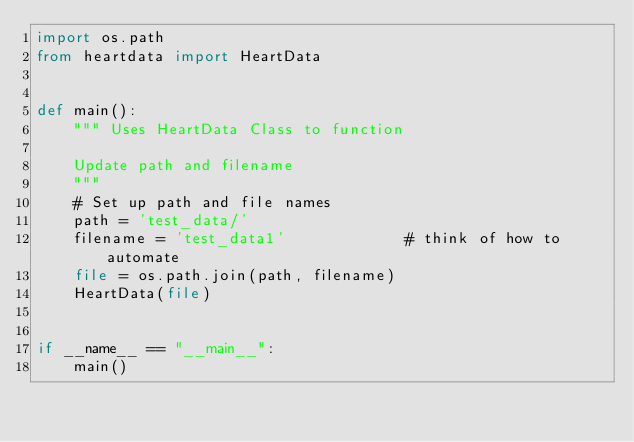Convert code to text. <code><loc_0><loc_0><loc_500><loc_500><_Python_>import os.path
from heartdata import HeartData


def main():
    """ Uses HeartData Class to function

    Update path and filename
    """
    # Set up path and file names
    path = 'test_data/'
    filename = 'test_data1'             # think of how to automate
    file = os.path.join(path, filename)
    HeartData(file)


if __name__ == "__main__":
    main()
</code> 